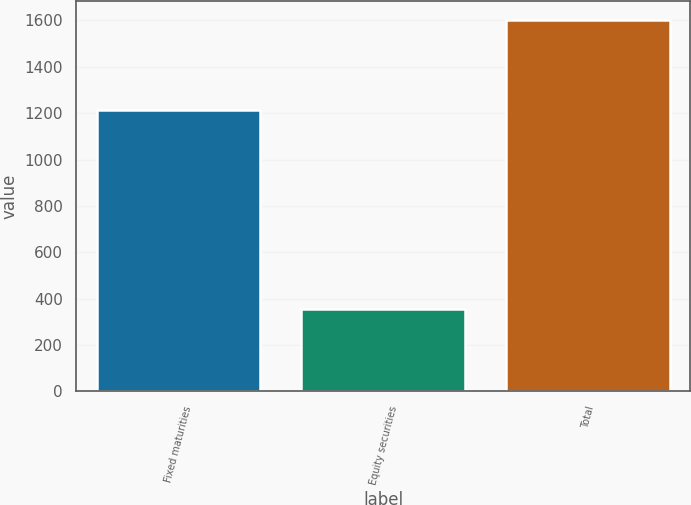Convert chart to OTSL. <chart><loc_0><loc_0><loc_500><loc_500><bar_chart><fcel>Fixed maturities<fcel>Equity securities<fcel>Total<nl><fcel>1214<fcel>354<fcel>1602<nl></chart> 